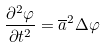<formula> <loc_0><loc_0><loc_500><loc_500>\frac { \partial ^ { 2 } \varphi } { \partial t ^ { 2 } } = \overline { a } ^ { 2 } \Delta \varphi</formula> 